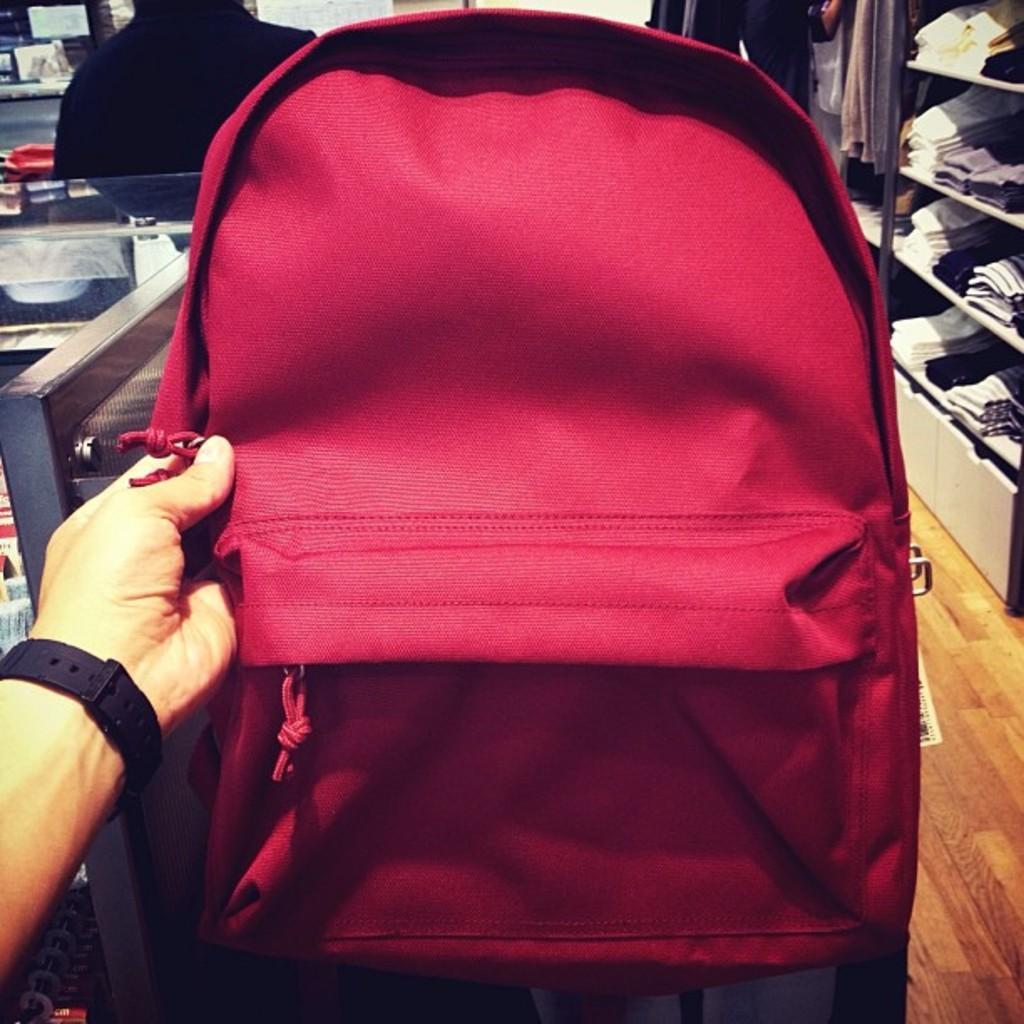Please provide a concise description of this image. a person is holding a bag 